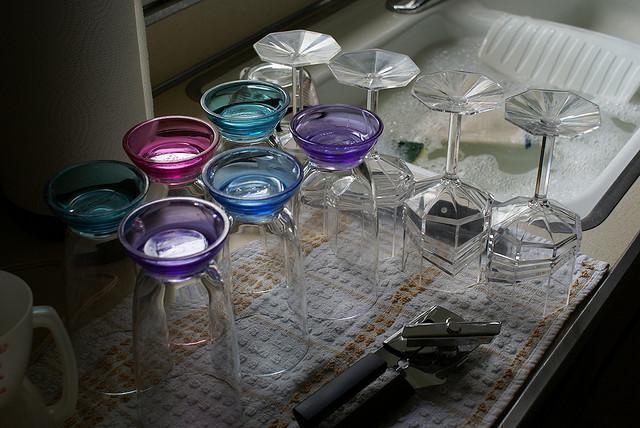How many wine glasses are in the photo?
Give a very brief answer. 4. How many sinks are in the photo?
Give a very brief answer. 1. How many cups can be seen?
Give a very brief answer. 7. 